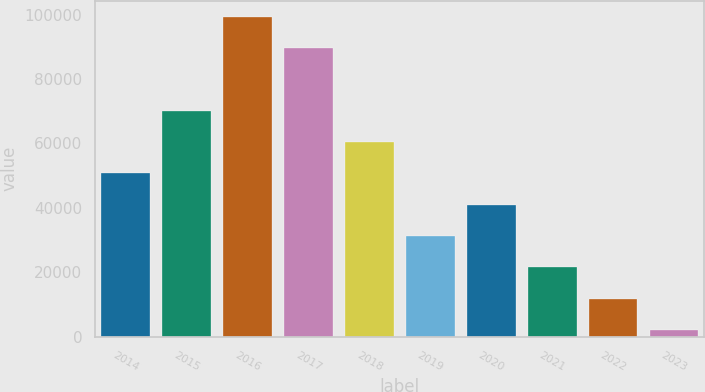<chart> <loc_0><loc_0><loc_500><loc_500><bar_chart><fcel>2014<fcel>2015<fcel>2016<fcel>2017<fcel>2018<fcel>2019<fcel>2020<fcel>2021<fcel>2022<fcel>2023<nl><fcel>50740<fcel>70195.6<fcel>99379<fcel>89651.2<fcel>60467.8<fcel>31284.4<fcel>41012.2<fcel>21556.6<fcel>11828.8<fcel>2101<nl></chart> 